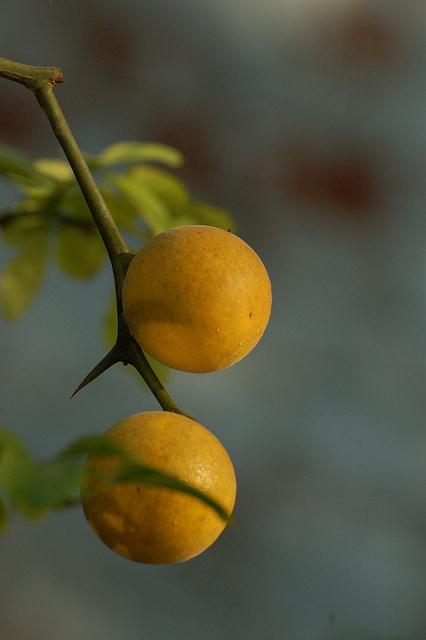What kind of fruit is this?
Give a very brief answer. Orange. What fruit is in the picture?
Short answer required. Orange. How many pieces of fruit are in this photograph?
Be succinct. 2. What color is the fruit?
Write a very short answer. Yellow. 